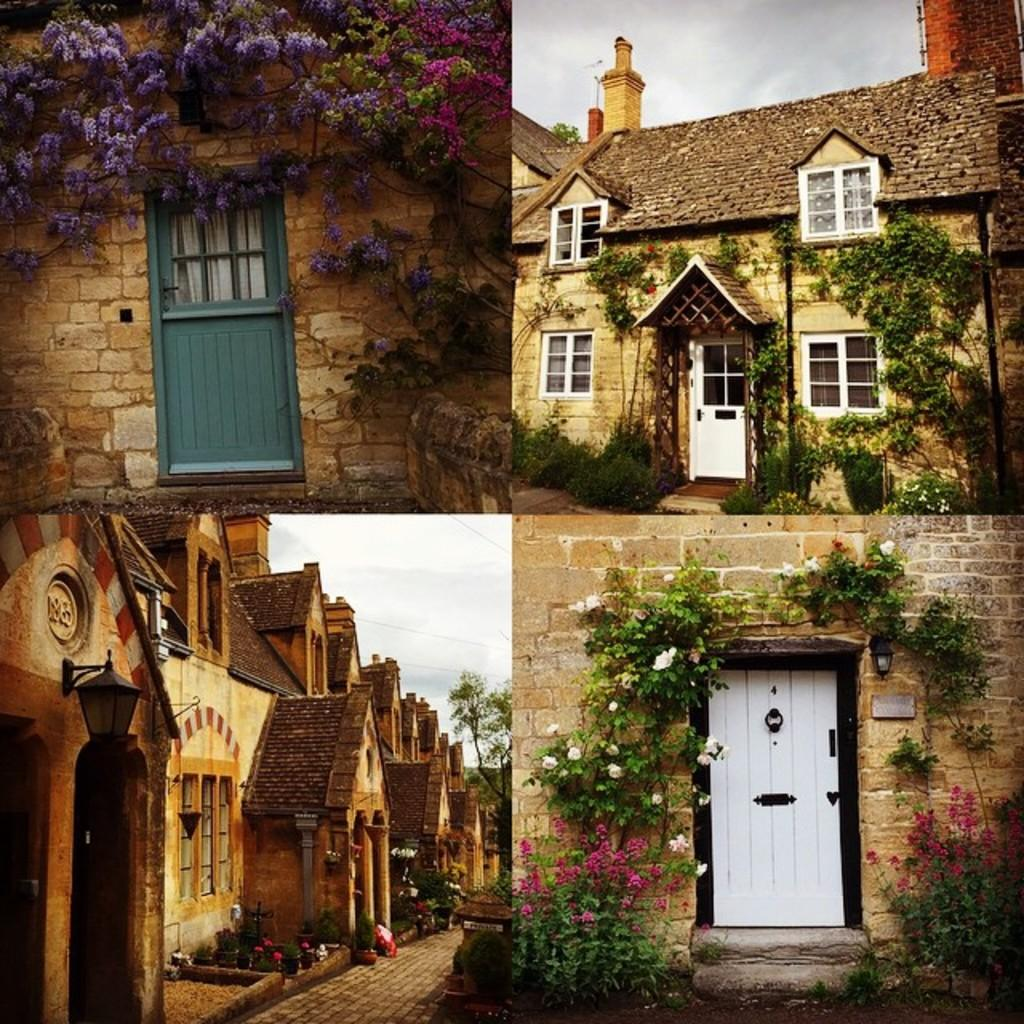What type of structures are present in the image? The image contains houses. What type of natural elements are present in the image? The image contains plants. What type of architectural features are present in the image? The image contains walls, doors, and windows. Can you describe any unspecified objects in the image? There are unspecified objects in the image, but their nature is not mentioned in the provided facts. What is the annual income of the residents in the image? There is no information about the residents' income in the image or the provided facts. What type of development is taking place in the image? There is no information about any development in the image or the provided facts. 